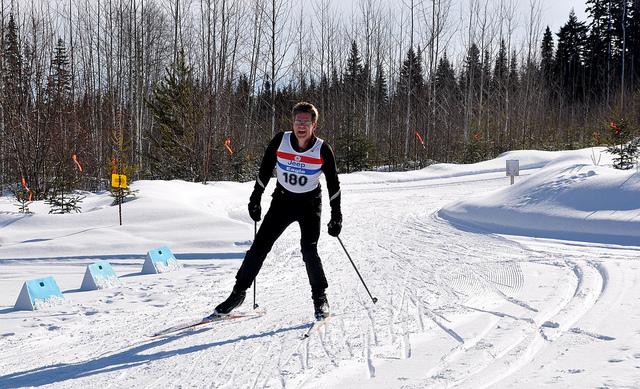Is the man wearing glasses?
Short answer required. Yes. What numbers are on the man in green's shirt?
Be succinct. 180. What number is this woman in the ski race?
Answer briefly. 180. Is this person snowboarding?
Short answer required. No. Where is the yellow sign?
Short answer required. Left. 